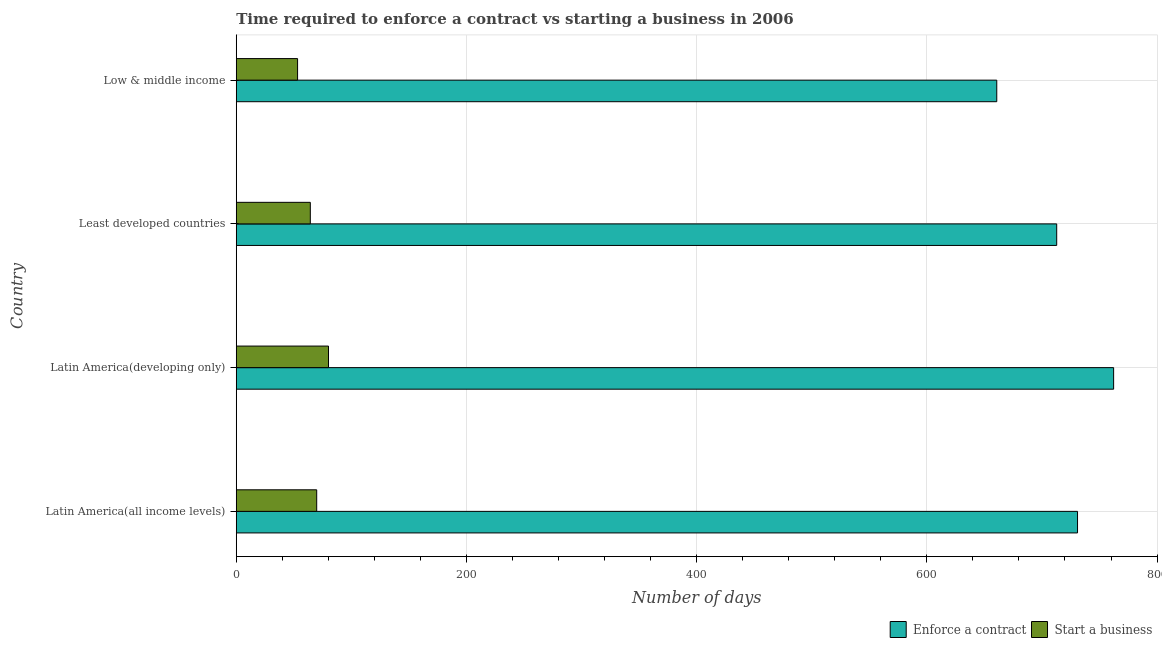How many different coloured bars are there?
Your response must be concise. 2. How many groups of bars are there?
Make the answer very short. 4. Are the number of bars on each tick of the Y-axis equal?
Offer a terse response. Yes. How many bars are there on the 3rd tick from the top?
Provide a succinct answer. 2. How many bars are there on the 4th tick from the bottom?
Provide a succinct answer. 2. What is the label of the 2nd group of bars from the top?
Give a very brief answer. Least developed countries. In how many cases, is the number of bars for a given country not equal to the number of legend labels?
Your answer should be compact. 0. What is the number of days to enforece a contract in Latin America(developing only)?
Give a very brief answer. 762.29. Across all countries, what is the maximum number of days to start a business?
Provide a short and direct response. 80.14. Across all countries, what is the minimum number of days to enforece a contract?
Offer a terse response. 660.76. In which country was the number of days to start a business maximum?
Keep it short and to the point. Latin America(developing only). In which country was the number of days to enforece a contract minimum?
Make the answer very short. Low & middle income. What is the total number of days to start a business in the graph?
Offer a terse response. 267.67. What is the difference between the number of days to enforece a contract in Latin America(developing only) and that in Least developed countries?
Ensure brevity in your answer.  49.45. What is the difference between the number of days to start a business in Latin America(developing only) and the number of days to enforece a contract in Latin America(all income levels)?
Your answer should be compact. -650.79. What is the average number of days to enforece a contract per country?
Provide a short and direct response. 716.7. What is the difference between the number of days to start a business and number of days to enforece a contract in Least developed countries?
Offer a terse response. -648.49. Is the difference between the number of days to start a business in Latin America(developing only) and Least developed countries greater than the difference between the number of days to enforece a contract in Latin America(developing only) and Least developed countries?
Your answer should be very brief. No. What is the difference between the highest and the second highest number of days to start a business?
Ensure brevity in your answer.  10.25. What is the difference between the highest and the lowest number of days to start a business?
Offer a terse response. 26.86. In how many countries, is the number of days to start a business greater than the average number of days to start a business taken over all countries?
Offer a terse response. 2. What does the 1st bar from the top in Least developed countries represents?
Give a very brief answer. Start a business. What does the 1st bar from the bottom in Low & middle income represents?
Keep it short and to the point. Enforce a contract. What is the difference between two consecutive major ticks on the X-axis?
Make the answer very short. 200. Does the graph contain any zero values?
Your answer should be very brief. No. How are the legend labels stacked?
Offer a very short reply. Horizontal. What is the title of the graph?
Your response must be concise. Time required to enforce a contract vs starting a business in 2006. What is the label or title of the X-axis?
Give a very brief answer. Number of days. What is the label or title of the Y-axis?
Provide a short and direct response. Country. What is the Number of days of Enforce a contract in Latin America(all income levels)?
Provide a succinct answer. 730.93. What is the Number of days in Start a business in Latin America(all income levels)?
Keep it short and to the point. 69.9. What is the Number of days of Enforce a contract in Latin America(developing only)?
Provide a succinct answer. 762.29. What is the Number of days of Start a business in Latin America(developing only)?
Your answer should be compact. 80.14. What is the Number of days in Enforce a contract in Least developed countries?
Your answer should be compact. 712.84. What is the Number of days of Start a business in Least developed countries?
Your answer should be compact. 64.35. What is the Number of days of Enforce a contract in Low & middle income?
Make the answer very short. 660.76. What is the Number of days of Start a business in Low & middle income?
Offer a terse response. 53.28. Across all countries, what is the maximum Number of days of Enforce a contract?
Keep it short and to the point. 762.29. Across all countries, what is the maximum Number of days in Start a business?
Provide a succinct answer. 80.14. Across all countries, what is the minimum Number of days in Enforce a contract?
Provide a succinct answer. 660.76. Across all countries, what is the minimum Number of days in Start a business?
Provide a short and direct response. 53.28. What is the total Number of days of Enforce a contract in the graph?
Ensure brevity in your answer.  2866.81. What is the total Number of days in Start a business in the graph?
Provide a short and direct response. 267.67. What is the difference between the Number of days in Enforce a contract in Latin America(all income levels) and that in Latin America(developing only)?
Offer a very short reply. -31.35. What is the difference between the Number of days in Start a business in Latin America(all income levels) and that in Latin America(developing only)?
Give a very brief answer. -10.25. What is the difference between the Number of days of Enforce a contract in Latin America(all income levels) and that in Least developed countries?
Your response must be concise. 18.09. What is the difference between the Number of days of Start a business in Latin America(all income levels) and that in Least developed countries?
Your answer should be compact. 5.55. What is the difference between the Number of days in Enforce a contract in Latin America(all income levels) and that in Low & middle income?
Give a very brief answer. 70.17. What is the difference between the Number of days in Start a business in Latin America(all income levels) and that in Low & middle income?
Offer a terse response. 16.61. What is the difference between the Number of days of Enforce a contract in Latin America(developing only) and that in Least developed countries?
Your answer should be compact. 49.45. What is the difference between the Number of days in Start a business in Latin America(developing only) and that in Least developed countries?
Your answer should be compact. 15.79. What is the difference between the Number of days in Enforce a contract in Latin America(developing only) and that in Low & middle income?
Provide a short and direct response. 101.53. What is the difference between the Number of days of Start a business in Latin America(developing only) and that in Low & middle income?
Provide a short and direct response. 26.86. What is the difference between the Number of days of Enforce a contract in Least developed countries and that in Low & middle income?
Give a very brief answer. 52.08. What is the difference between the Number of days of Start a business in Least developed countries and that in Low & middle income?
Ensure brevity in your answer.  11.07. What is the difference between the Number of days of Enforce a contract in Latin America(all income levels) and the Number of days of Start a business in Latin America(developing only)?
Provide a succinct answer. 650.79. What is the difference between the Number of days in Enforce a contract in Latin America(all income levels) and the Number of days in Start a business in Least developed countries?
Ensure brevity in your answer.  666.58. What is the difference between the Number of days in Enforce a contract in Latin America(all income levels) and the Number of days in Start a business in Low & middle income?
Provide a succinct answer. 677.65. What is the difference between the Number of days of Enforce a contract in Latin America(developing only) and the Number of days of Start a business in Least developed countries?
Your answer should be very brief. 697.94. What is the difference between the Number of days in Enforce a contract in Latin America(developing only) and the Number of days in Start a business in Low & middle income?
Ensure brevity in your answer.  709. What is the difference between the Number of days in Enforce a contract in Least developed countries and the Number of days in Start a business in Low & middle income?
Offer a very short reply. 659.56. What is the average Number of days of Enforce a contract per country?
Your answer should be compact. 716.7. What is the average Number of days in Start a business per country?
Your response must be concise. 66.92. What is the difference between the Number of days in Enforce a contract and Number of days in Start a business in Latin America(all income levels)?
Offer a terse response. 661.03. What is the difference between the Number of days in Enforce a contract and Number of days in Start a business in Latin America(developing only)?
Provide a succinct answer. 682.14. What is the difference between the Number of days in Enforce a contract and Number of days in Start a business in Least developed countries?
Your answer should be compact. 648.49. What is the difference between the Number of days of Enforce a contract and Number of days of Start a business in Low & middle income?
Your response must be concise. 607.48. What is the ratio of the Number of days of Enforce a contract in Latin America(all income levels) to that in Latin America(developing only)?
Provide a succinct answer. 0.96. What is the ratio of the Number of days of Start a business in Latin America(all income levels) to that in Latin America(developing only)?
Your answer should be very brief. 0.87. What is the ratio of the Number of days in Enforce a contract in Latin America(all income levels) to that in Least developed countries?
Offer a terse response. 1.03. What is the ratio of the Number of days in Start a business in Latin America(all income levels) to that in Least developed countries?
Make the answer very short. 1.09. What is the ratio of the Number of days of Enforce a contract in Latin America(all income levels) to that in Low & middle income?
Your answer should be compact. 1.11. What is the ratio of the Number of days of Start a business in Latin America(all income levels) to that in Low & middle income?
Give a very brief answer. 1.31. What is the ratio of the Number of days of Enforce a contract in Latin America(developing only) to that in Least developed countries?
Your answer should be very brief. 1.07. What is the ratio of the Number of days of Start a business in Latin America(developing only) to that in Least developed countries?
Offer a very short reply. 1.25. What is the ratio of the Number of days of Enforce a contract in Latin America(developing only) to that in Low & middle income?
Your answer should be compact. 1.15. What is the ratio of the Number of days in Start a business in Latin America(developing only) to that in Low & middle income?
Keep it short and to the point. 1.5. What is the ratio of the Number of days of Enforce a contract in Least developed countries to that in Low & middle income?
Offer a terse response. 1.08. What is the ratio of the Number of days in Start a business in Least developed countries to that in Low & middle income?
Provide a succinct answer. 1.21. What is the difference between the highest and the second highest Number of days of Enforce a contract?
Make the answer very short. 31.35. What is the difference between the highest and the second highest Number of days of Start a business?
Offer a very short reply. 10.25. What is the difference between the highest and the lowest Number of days of Enforce a contract?
Keep it short and to the point. 101.53. What is the difference between the highest and the lowest Number of days in Start a business?
Provide a succinct answer. 26.86. 